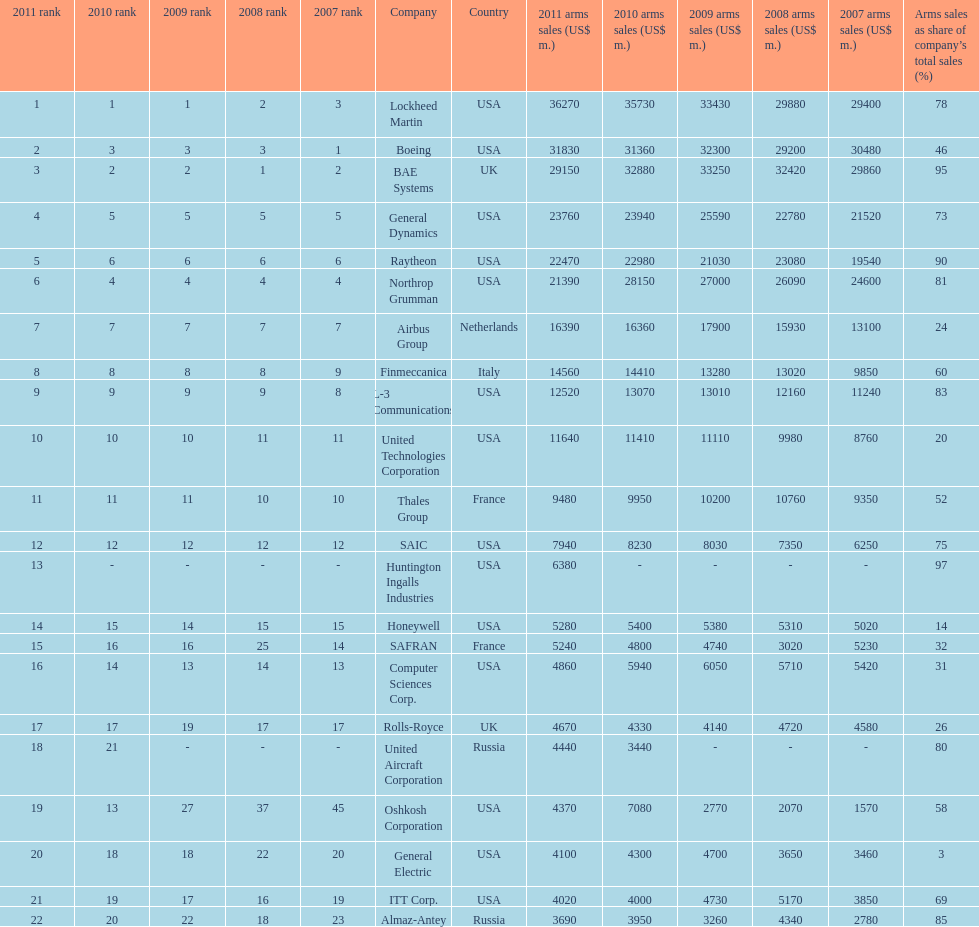Calculate the difference between boeing's 2010 arms sales and raytheon's 2010 arms sales. 8380. 